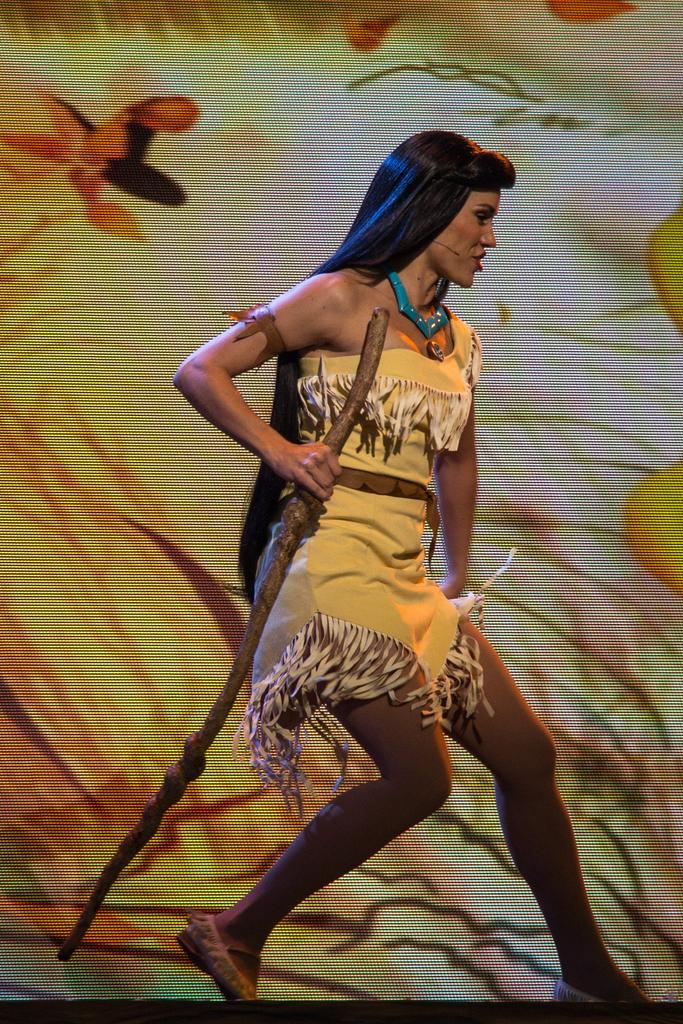Who is present in the image? There is a woman in the image. What is the woman holding in the image? The woman is holding a stick. What can be seen in the background of the image? There is a poster or curtain in the background of the image. How does the woman contribute to reducing pollution in the image? There is no indication in the image that the woman is contributing to reducing pollution. 